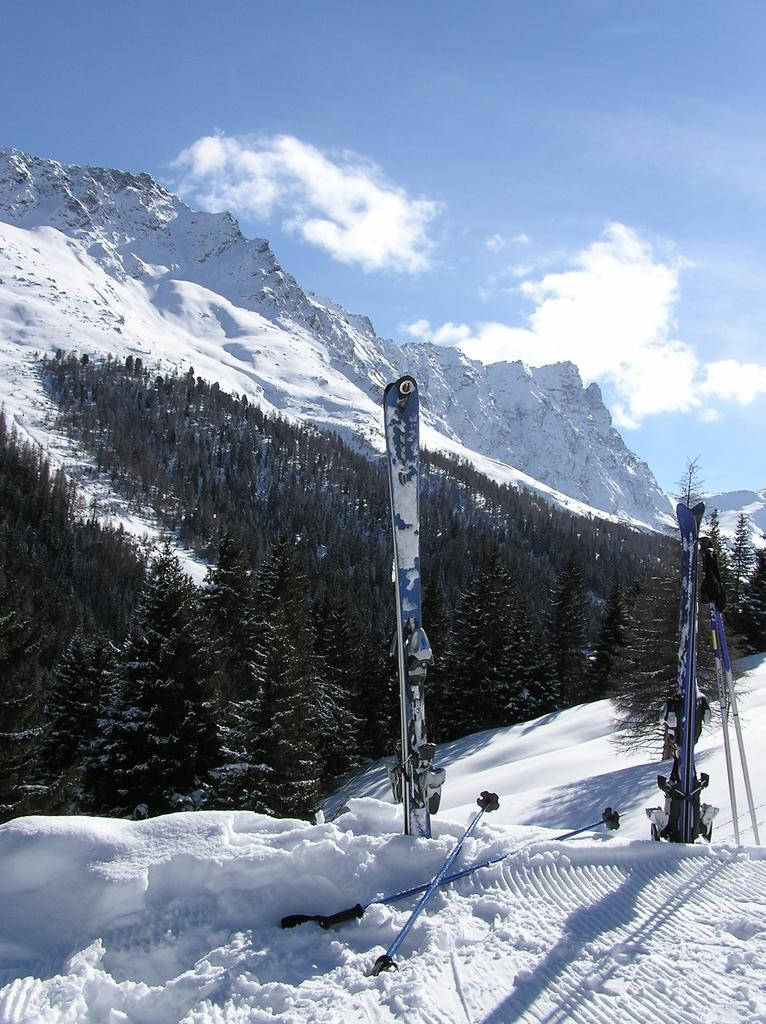What type of equipment is visible in the image? There are ski-boards and sticks (likely ski poles) in the image. Where are the ski-boards and sticks located? The ski-boards and sticks are on the snow in the image. What can be seen in the background of the image? There are trees, mountains, clouds, and the sky visible in the background of the image. What type of bait is used to catch fish in the image? There is no fishing or bait present in the image; it features ski-boards, sticks, snow, trees, mountains, clouds, and the sky. Can you describe the taste of the tongue in the image? There is no tongue present in the image. 